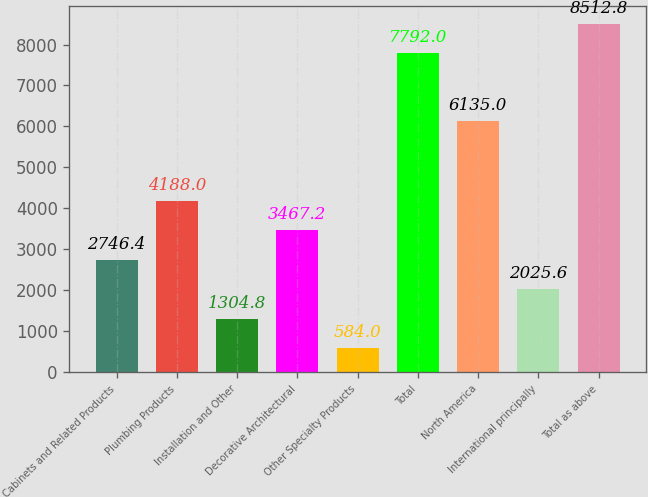<chart> <loc_0><loc_0><loc_500><loc_500><bar_chart><fcel>Cabinets and Related Products<fcel>Plumbing Products<fcel>Installation and Other<fcel>Decorative Architectural<fcel>Other Specialty Products<fcel>Total<fcel>North America<fcel>International principally<fcel>Total as above<nl><fcel>2746.4<fcel>4188<fcel>1304.8<fcel>3467.2<fcel>584<fcel>7792<fcel>6135<fcel>2025.6<fcel>8512.8<nl></chart> 